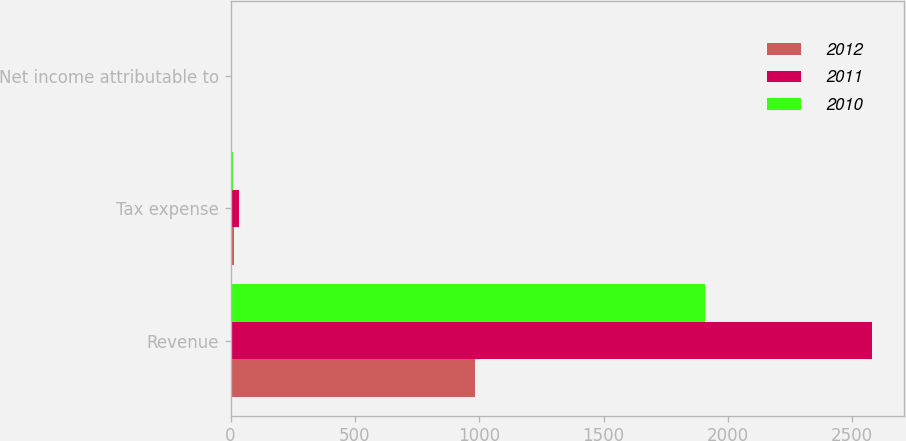<chart> <loc_0><loc_0><loc_500><loc_500><stacked_bar_chart><ecel><fcel>Revenue<fcel>Tax expense<fcel>Net income attributable to<nl><fcel>2012<fcel>982<fcel>15<fcel>5<nl><fcel>2011<fcel>2581<fcel>36<fcel>6<nl><fcel>2010<fcel>1908<fcel>11<fcel>1<nl></chart> 